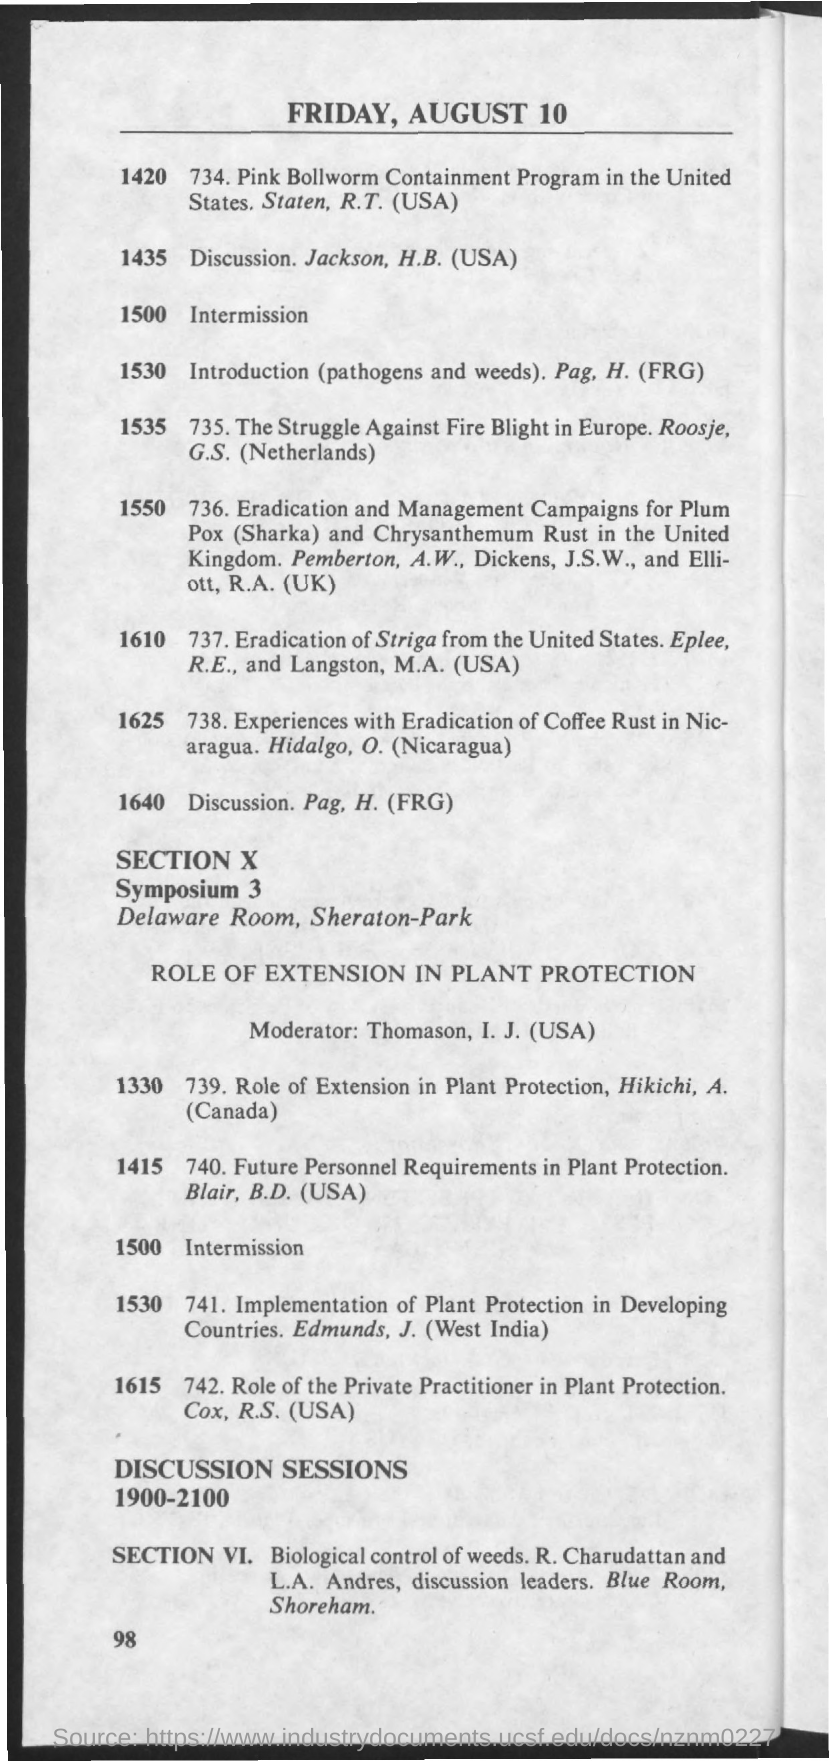What is the date mentioned in the document?
Your answer should be very brief. Friday, August 10. Which topic is on page number 1640?
Keep it short and to the point. Discussion. pag, h. (frg). 